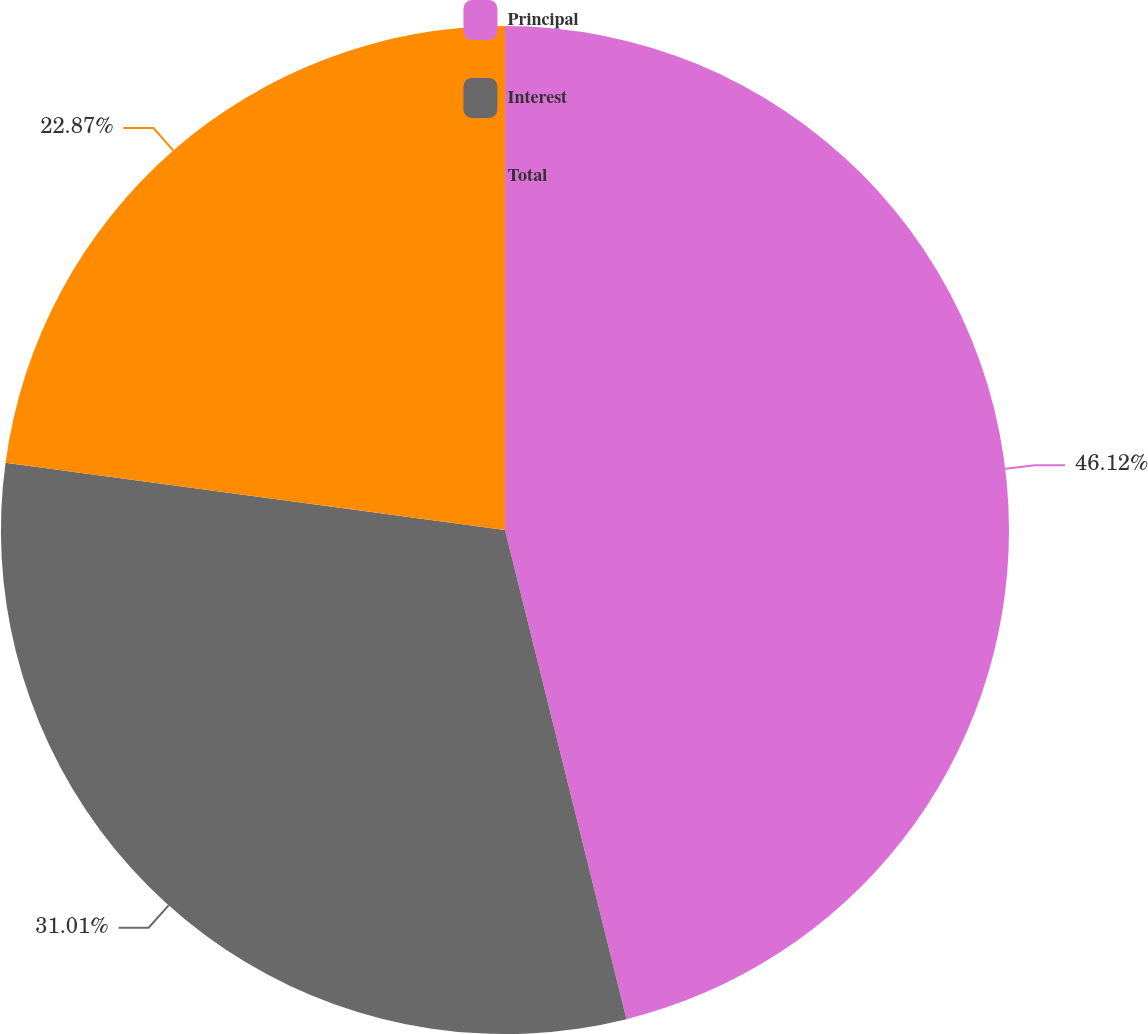<chart> <loc_0><loc_0><loc_500><loc_500><pie_chart><fcel>Principal<fcel>Interest<fcel>Total<nl><fcel>46.13%<fcel>31.01%<fcel>22.87%<nl></chart> 